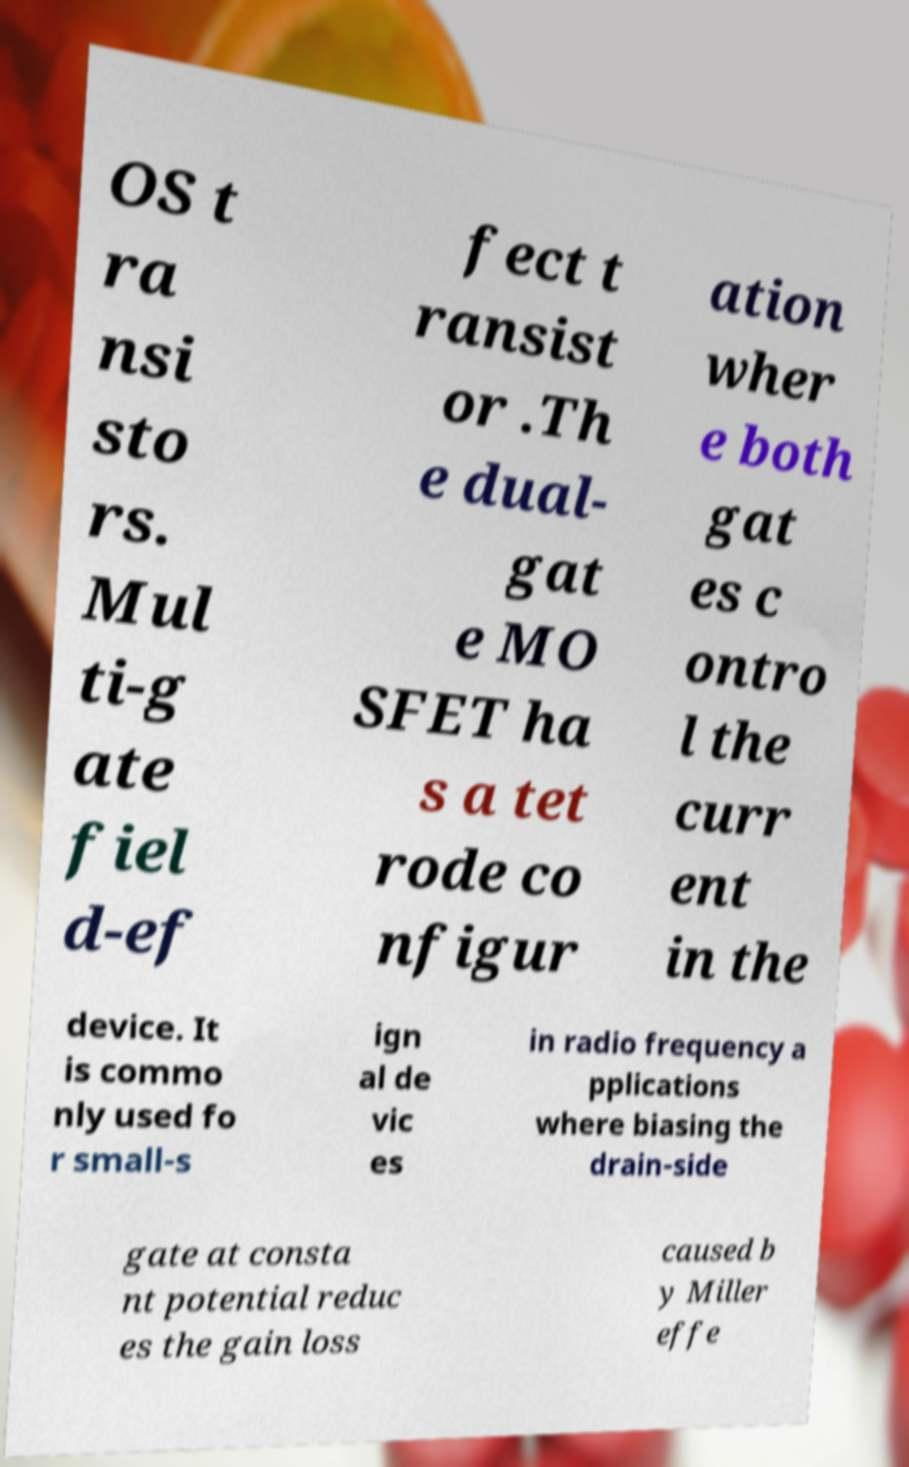Can you accurately transcribe the text from the provided image for me? OS t ra nsi sto rs. Mul ti-g ate fiel d-ef fect t ransist or .Th e dual- gat e MO SFET ha s a tet rode co nfigur ation wher e both gat es c ontro l the curr ent in the device. It is commo nly used fo r small-s ign al de vic es in radio frequency a pplications where biasing the drain-side gate at consta nt potential reduc es the gain loss caused b y Miller effe 